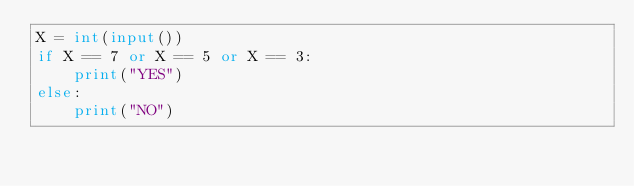<code> <loc_0><loc_0><loc_500><loc_500><_Python_>X = int(input())
if X == 7 or X == 5 or X == 3:
    print("YES")
else:
    print("NO")
</code> 